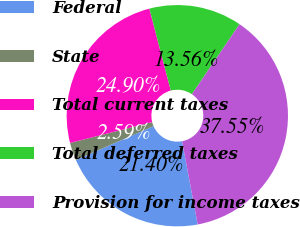<chart> <loc_0><loc_0><loc_500><loc_500><pie_chart><fcel>Federal<fcel>State<fcel>Total current taxes<fcel>Total deferred taxes<fcel>Provision for income taxes<nl><fcel>21.4%<fcel>2.59%<fcel>24.9%<fcel>13.56%<fcel>37.55%<nl></chart> 